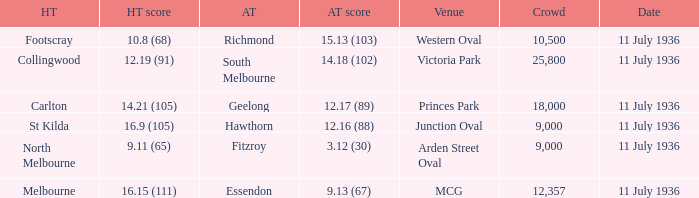Parse the full table. {'header': ['HT', 'HT score', 'AT', 'AT score', 'Venue', 'Crowd', 'Date'], 'rows': [['Footscray', '10.8 (68)', 'Richmond', '15.13 (103)', 'Western Oval', '10,500', '11 July 1936'], ['Collingwood', '12.19 (91)', 'South Melbourne', '14.18 (102)', 'Victoria Park', '25,800', '11 July 1936'], ['Carlton', '14.21 (105)', 'Geelong', '12.17 (89)', 'Princes Park', '18,000', '11 July 1936'], ['St Kilda', '16.9 (105)', 'Hawthorn', '12.16 (88)', 'Junction Oval', '9,000', '11 July 1936'], ['North Melbourne', '9.11 (65)', 'Fitzroy', '3.12 (30)', 'Arden Street Oval', '9,000', '11 July 1936'], ['Melbourne', '16.15 (111)', 'Essendon', '9.13 (67)', 'MCG', '12,357', '11 July 1936']]} When was the game with richmond as Away team? 11 July 1936. 